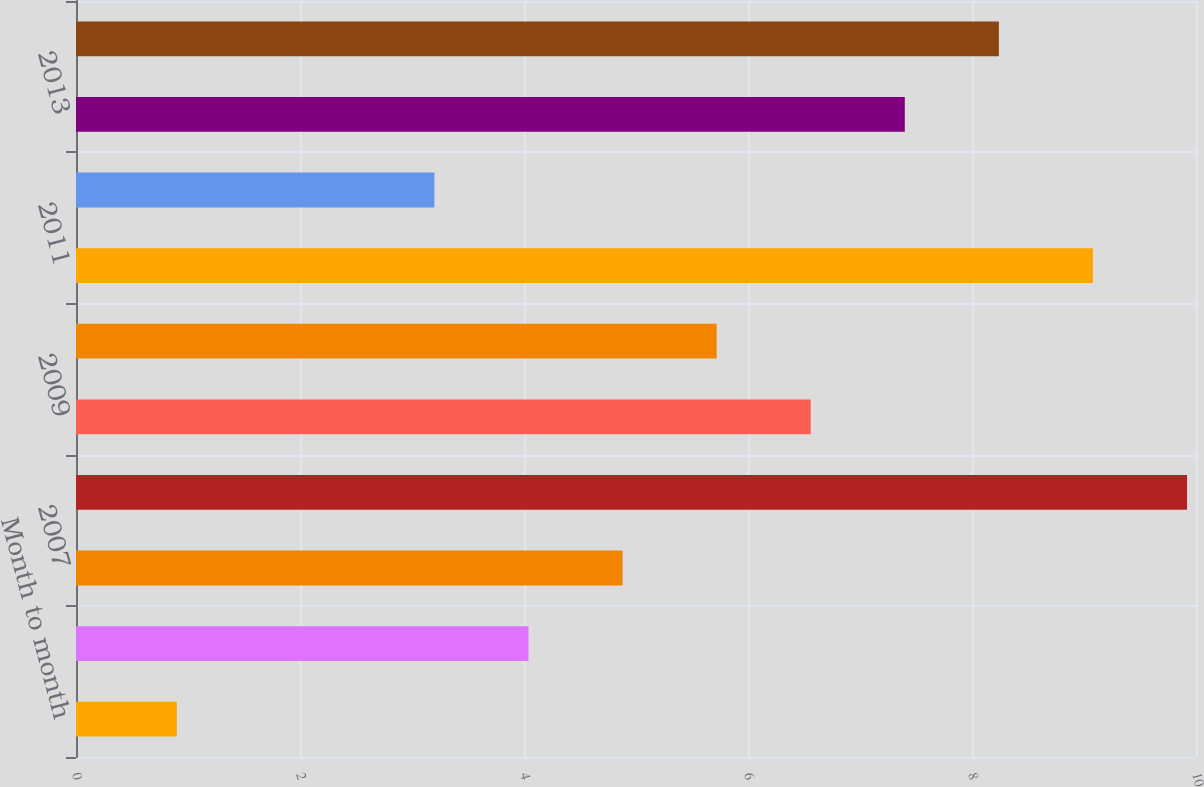Convert chart to OTSL. <chart><loc_0><loc_0><loc_500><loc_500><bar_chart><fcel>Month to month<fcel>2006<fcel>2007<fcel>2008<fcel>2009<fcel>2010<fcel>2011<fcel>2012<fcel>2013<fcel>2014<nl><fcel>0.9<fcel>4.04<fcel>4.88<fcel>9.92<fcel>6.56<fcel>5.72<fcel>9.08<fcel>3.2<fcel>7.4<fcel>8.24<nl></chart> 